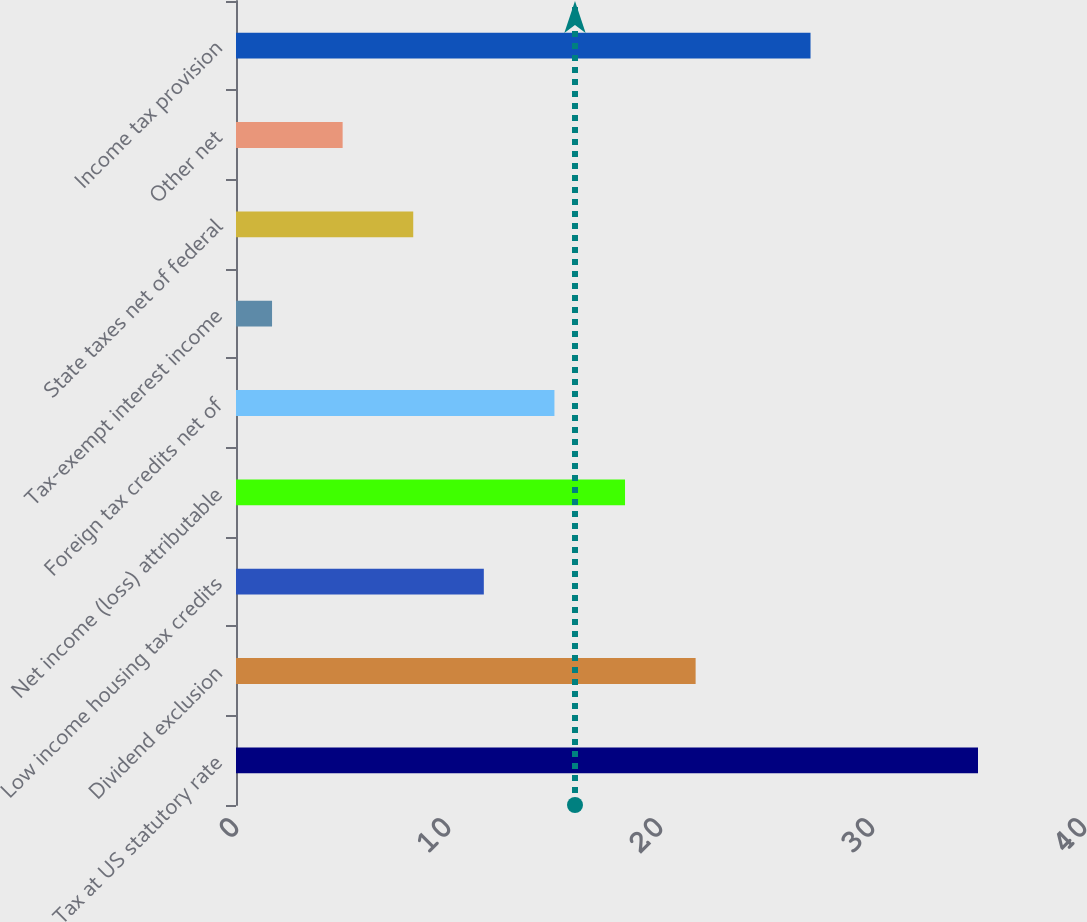<chart> <loc_0><loc_0><loc_500><loc_500><bar_chart><fcel>Tax at US statutory rate<fcel>Dividend exclusion<fcel>Low income housing tax credits<fcel>Net income (loss) attributable<fcel>Foreign tax credits net of<fcel>Tax-exempt interest income<fcel>State taxes net of federal<fcel>Other net<fcel>Income tax provision<nl><fcel>35<fcel>21.68<fcel>11.69<fcel>18.35<fcel>15.02<fcel>1.7<fcel>8.36<fcel>5.03<fcel>27.1<nl></chart> 